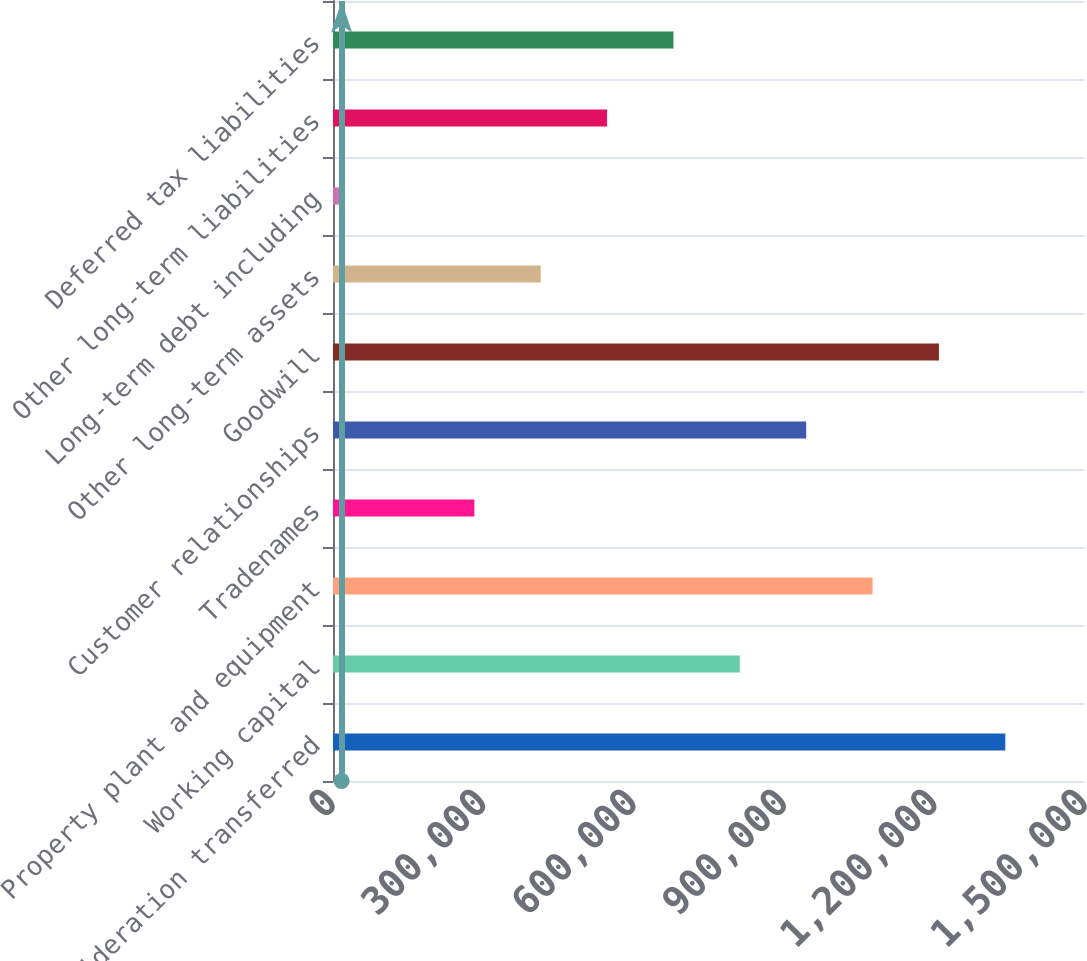<chart> <loc_0><loc_0><loc_500><loc_500><bar_chart><fcel>Consideration transferred<fcel>Working capital<fcel>Property plant and equipment<fcel>Tradenames<fcel>Customer relationships<fcel>Goodwill<fcel>Other long-term assets<fcel>Long-term debt including<fcel>Other long-term liabilities<fcel>Deferred tax liabilities<nl><fcel>1.34105e+06<fcel>811488<fcel>1.07627e+06<fcel>281927<fcel>943879<fcel>1.20866e+06<fcel>414317<fcel>17146<fcel>546708<fcel>679098<nl></chart> 